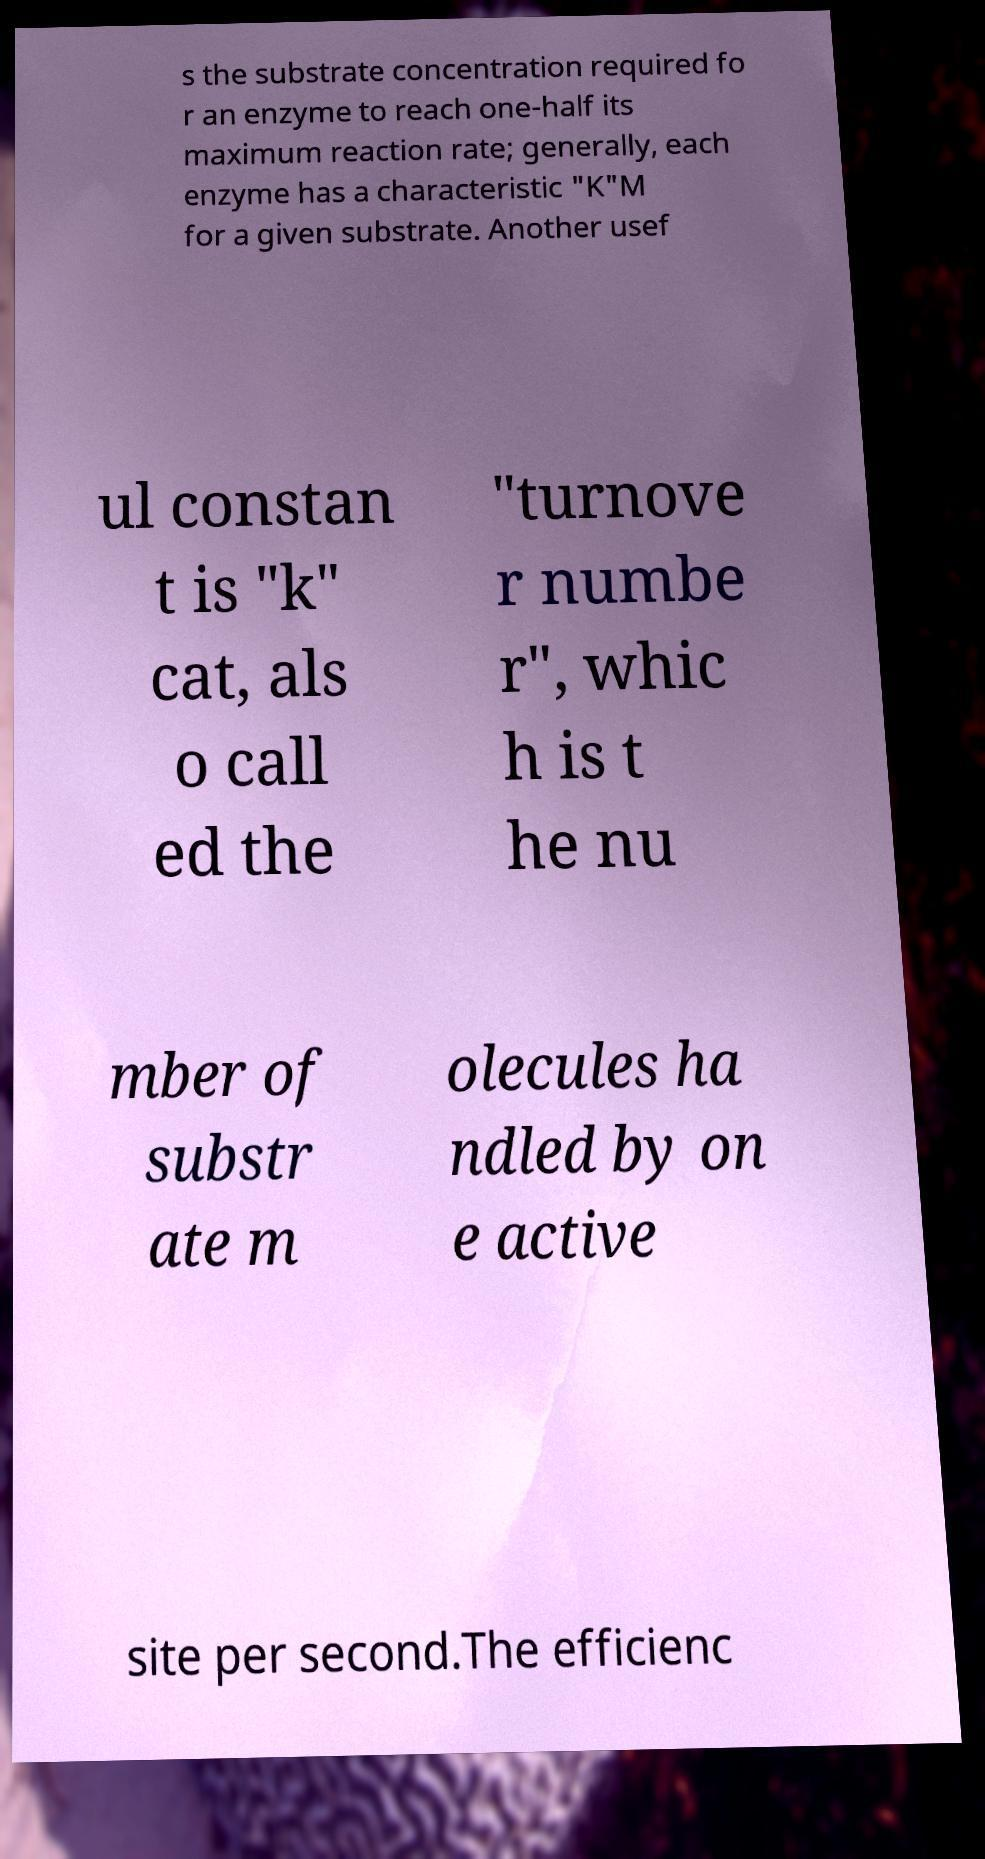Can you read and provide the text displayed in the image?This photo seems to have some interesting text. Can you extract and type it out for me? s the substrate concentration required fo r an enzyme to reach one-half its maximum reaction rate; generally, each enzyme has a characteristic "K"M for a given substrate. Another usef ul constan t is "k" cat, als o call ed the "turnove r numbe r", whic h is t he nu mber of substr ate m olecules ha ndled by on e active site per second.The efficienc 